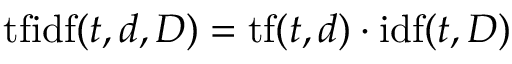Convert formula to latex. <formula><loc_0><loc_0><loc_500><loc_500>t f i d f ( t , d , D ) = t f ( t , d ) \cdot i d f ( t , D )</formula> 